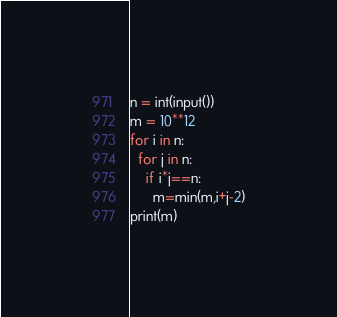<code> <loc_0><loc_0><loc_500><loc_500><_Python_>n = int(input())
m = 10**12
for i in n:
  for j in n:
    if i*j==n:
      m=min(m,i+j-2)
print(m)</code> 